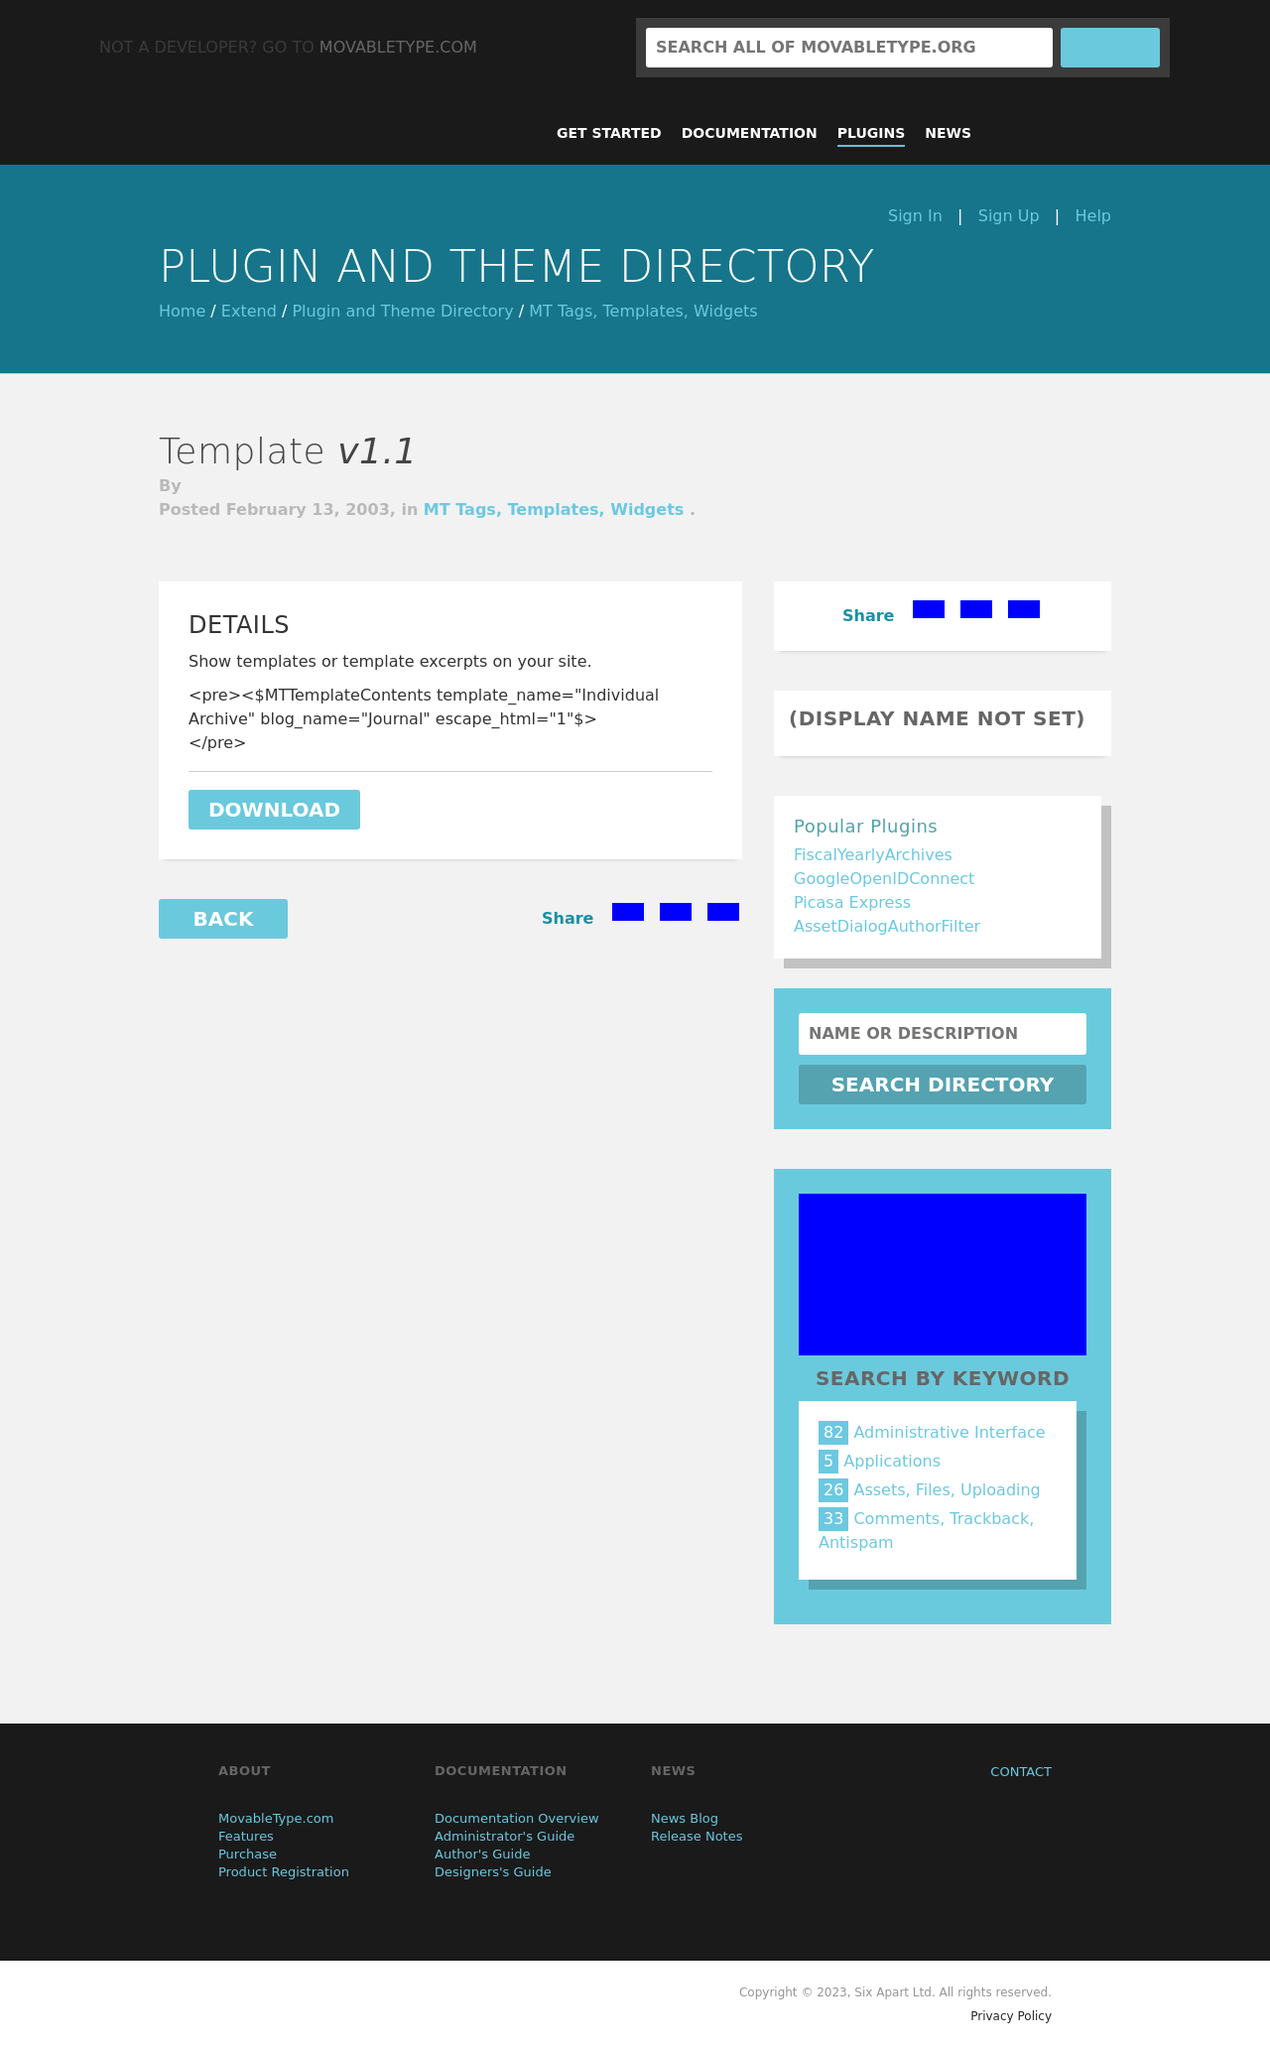What are some tips for ensuring the 'Popular Plugins' list is accessible and user-friendly in HTML? For an accessible and user-friendly 'Popular Plugins' list, use semantic HTML by implementing an <aside> tag to define the section as related content. Inside, employ a <nav> element if the plugins are navigational links. Use meaningful <h4> headings for titles and an unordered <ul> for the list of items. Each plugin name should be enclosed in an <li> and linkable via <a> tags. Ensure proper contrast ratio for text and background for visibility and include `alt` text for any icons or images. Lastly, consider keyboard navigation by making sure that the list items can be tabbed through and selected using keyboard controls. 